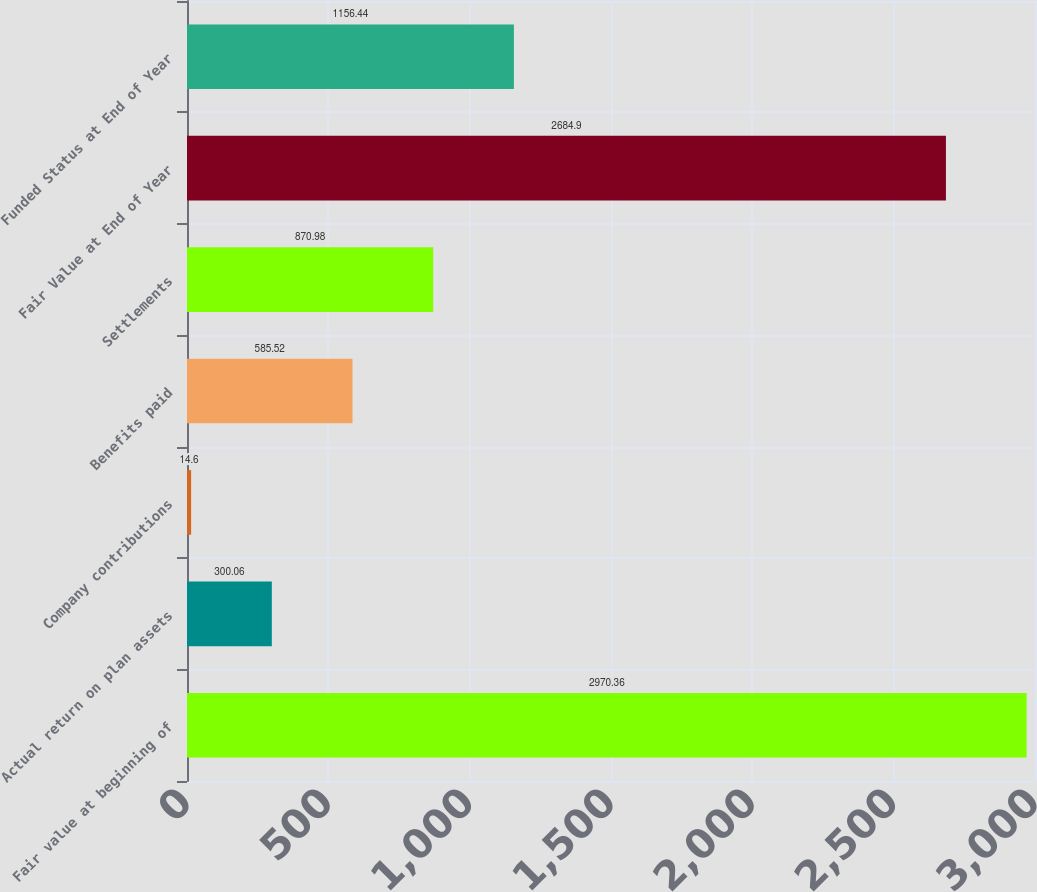<chart> <loc_0><loc_0><loc_500><loc_500><bar_chart><fcel>Fair value at beginning of<fcel>Actual return on plan assets<fcel>Company contributions<fcel>Benefits paid<fcel>Settlements<fcel>Fair Value at End of Year<fcel>Funded Status at End of Year<nl><fcel>2970.36<fcel>300.06<fcel>14.6<fcel>585.52<fcel>870.98<fcel>2684.9<fcel>1156.44<nl></chart> 